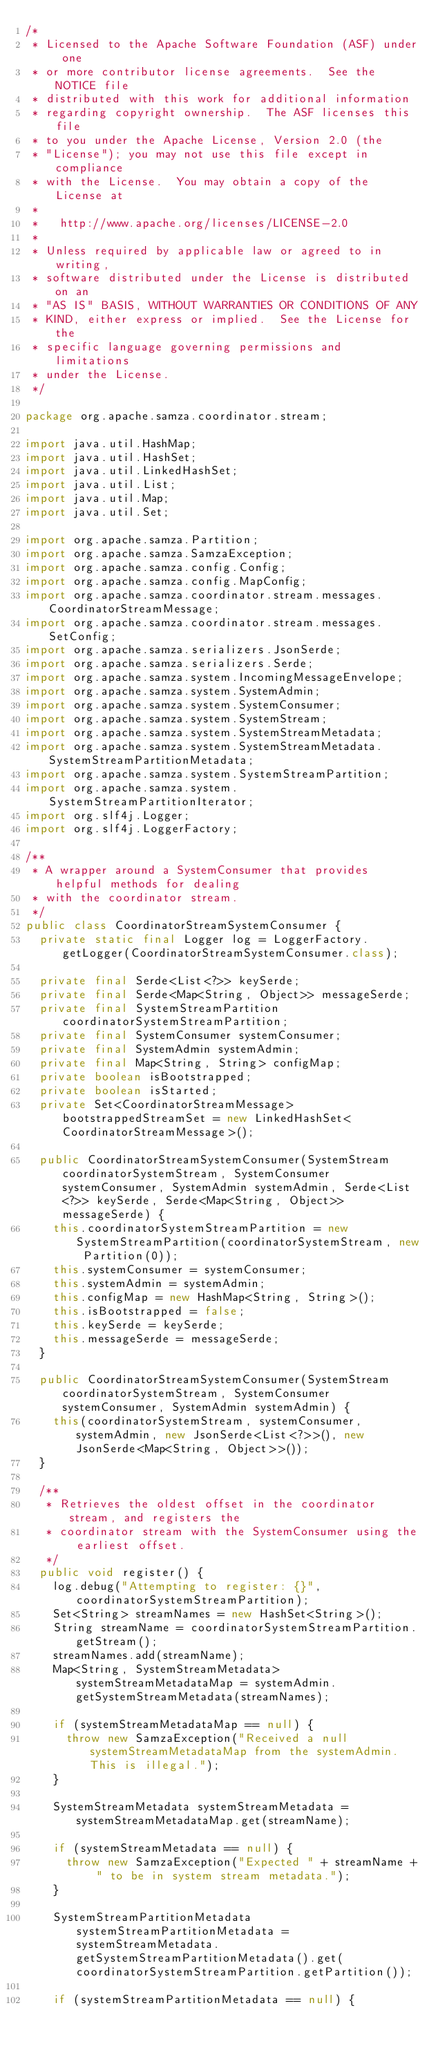Convert code to text. <code><loc_0><loc_0><loc_500><loc_500><_Java_>/*
 * Licensed to the Apache Software Foundation (ASF) under one
 * or more contributor license agreements.  See the NOTICE file
 * distributed with this work for additional information
 * regarding copyright ownership.  The ASF licenses this file
 * to you under the Apache License, Version 2.0 (the
 * "License"); you may not use this file except in compliance
 * with the License.  You may obtain a copy of the License at
 *
 *   http://www.apache.org/licenses/LICENSE-2.0
 *
 * Unless required by applicable law or agreed to in writing,
 * software distributed under the License is distributed on an
 * "AS IS" BASIS, WITHOUT WARRANTIES OR CONDITIONS OF ANY
 * KIND, either express or implied.  See the License for the
 * specific language governing permissions and limitations
 * under the License.
 */

package org.apache.samza.coordinator.stream;

import java.util.HashMap;
import java.util.HashSet;
import java.util.LinkedHashSet;
import java.util.List;
import java.util.Map;
import java.util.Set;

import org.apache.samza.Partition;
import org.apache.samza.SamzaException;
import org.apache.samza.config.Config;
import org.apache.samza.config.MapConfig;
import org.apache.samza.coordinator.stream.messages.CoordinatorStreamMessage;
import org.apache.samza.coordinator.stream.messages.SetConfig;
import org.apache.samza.serializers.JsonSerde;
import org.apache.samza.serializers.Serde;
import org.apache.samza.system.IncomingMessageEnvelope;
import org.apache.samza.system.SystemAdmin;
import org.apache.samza.system.SystemConsumer;
import org.apache.samza.system.SystemStream;
import org.apache.samza.system.SystemStreamMetadata;
import org.apache.samza.system.SystemStreamMetadata.SystemStreamPartitionMetadata;
import org.apache.samza.system.SystemStreamPartition;
import org.apache.samza.system.SystemStreamPartitionIterator;
import org.slf4j.Logger;
import org.slf4j.LoggerFactory;

/**
 * A wrapper around a SystemConsumer that provides helpful methods for dealing
 * with the coordinator stream.
 */
public class CoordinatorStreamSystemConsumer {
  private static final Logger log = LoggerFactory.getLogger(CoordinatorStreamSystemConsumer.class);

  private final Serde<List<?>> keySerde;
  private final Serde<Map<String, Object>> messageSerde;
  private final SystemStreamPartition coordinatorSystemStreamPartition;
  private final SystemConsumer systemConsumer;
  private final SystemAdmin systemAdmin;
  private final Map<String, String> configMap;
  private boolean isBootstrapped;
  private boolean isStarted;
  private Set<CoordinatorStreamMessage> bootstrappedStreamSet = new LinkedHashSet<CoordinatorStreamMessage>();

  public CoordinatorStreamSystemConsumer(SystemStream coordinatorSystemStream, SystemConsumer systemConsumer, SystemAdmin systemAdmin, Serde<List<?>> keySerde, Serde<Map<String, Object>> messageSerde) {
    this.coordinatorSystemStreamPartition = new SystemStreamPartition(coordinatorSystemStream, new Partition(0));
    this.systemConsumer = systemConsumer;
    this.systemAdmin = systemAdmin;
    this.configMap = new HashMap<String, String>();
    this.isBootstrapped = false;
    this.keySerde = keySerde;
    this.messageSerde = messageSerde;
  }

  public CoordinatorStreamSystemConsumer(SystemStream coordinatorSystemStream, SystemConsumer systemConsumer, SystemAdmin systemAdmin) {
    this(coordinatorSystemStream, systemConsumer, systemAdmin, new JsonSerde<List<?>>(), new JsonSerde<Map<String, Object>>());
  }

  /**
   * Retrieves the oldest offset in the coordinator stream, and registers the
   * coordinator stream with the SystemConsumer using the earliest offset.
   */
  public void register() {
    log.debug("Attempting to register: {}", coordinatorSystemStreamPartition);
    Set<String> streamNames = new HashSet<String>();
    String streamName = coordinatorSystemStreamPartition.getStream();
    streamNames.add(streamName);
    Map<String, SystemStreamMetadata> systemStreamMetadataMap = systemAdmin.getSystemStreamMetadata(streamNames);

    if (systemStreamMetadataMap == null) {
      throw new SamzaException("Received a null systemStreamMetadataMap from the systemAdmin. This is illegal.");
    }

    SystemStreamMetadata systemStreamMetadata = systemStreamMetadataMap.get(streamName);

    if (systemStreamMetadata == null) {
      throw new SamzaException("Expected " + streamName + " to be in system stream metadata.");
    }

    SystemStreamPartitionMetadata systemStreamPartitionMetadata = systemStreamMetadata.getSystemStreamPartitionMetadata().get(coordinatorSystemStreamPartition.getPartition());

    if (systemStreamPartitionMetadata == null) {</code> 